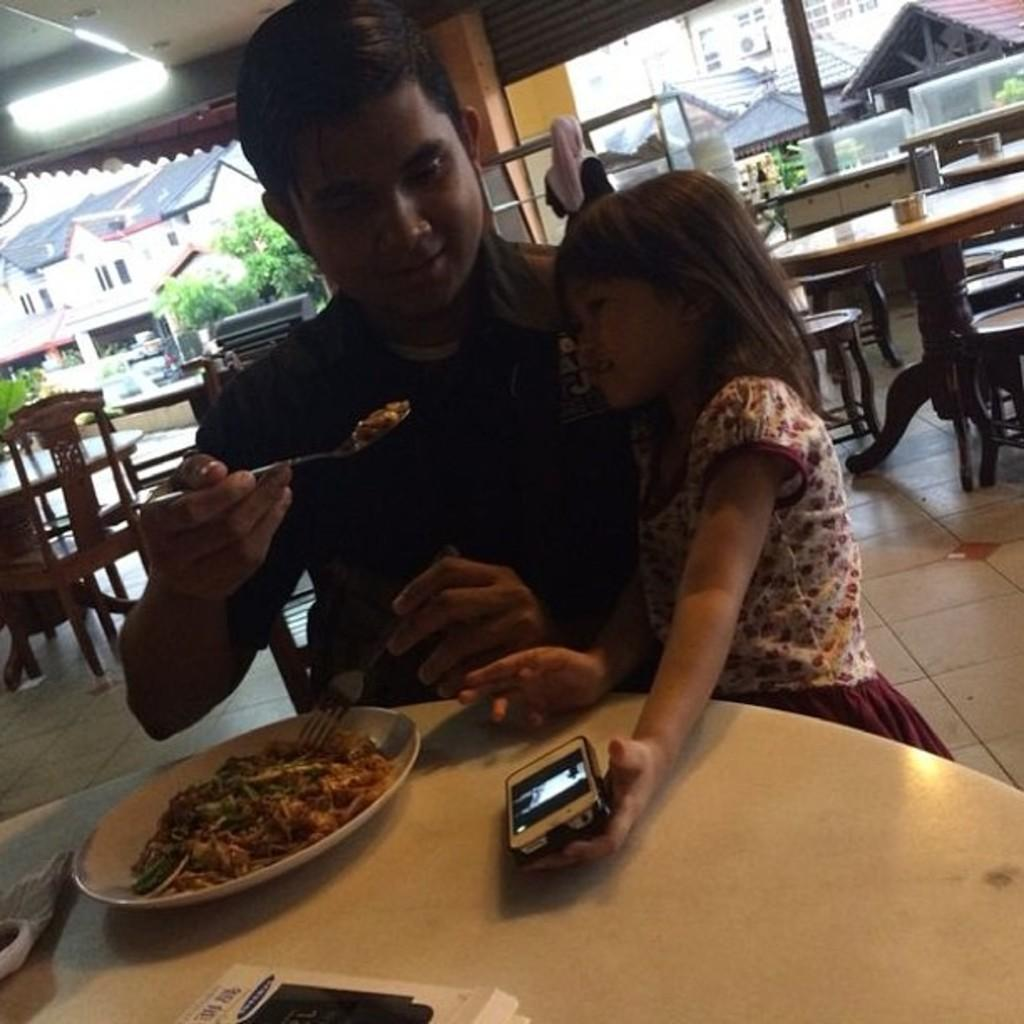Who is present in the image? There is a person in the image. What is the person holding in their hand? The person is holding a spoon in their hand. What is the person doing with the spoon? The person is feeding a kid in the image. What can be seen on top of the table? There is a food item on top of the table. What else is present on the table? There is a phone on the table. What type of copper material is visible in the image? There is no copper material present in the image. Is there a ball being played with in the image? There is no ball visible in the image. 